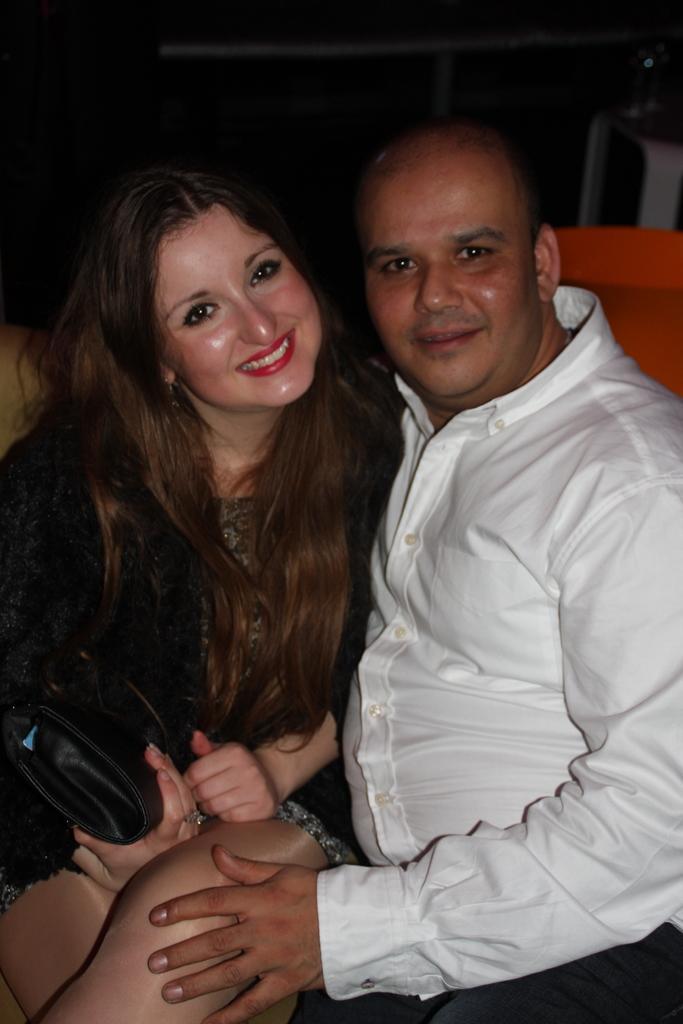Can you describe this image briefly? 2 people are sitting. The person at the left is wearing a white shirt. The person at the left is wearing a dress and holding a bag in her hand and smiling. 